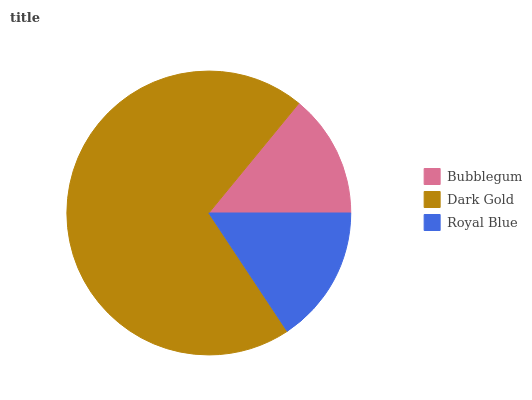Is Bubblegum the minimum?
Answer yes or no. Yes. Is Dark Gold the maximum?
Answer yes or no. Yes. Is Royal Blue the minimum?
Answer yes or no. No. Is Royal Blue the maximum?
Answer yes or no. No. Is Dark Gold greater than Royal Blue?
Answer yes or no. Yes. Is Royal Blue less than Dark Gold?
Answer yes or no. Yes. Is Royal Blue greater than Dark Gold?
Answer yes or no. No. Is Dark Gold less than Royal Blue?
Answer yes or no. No. Is Royal Blue the high median?
Answer yes or no. Yes. Is Royal Blue the low median?
Answer yes or no. Yes. Is Dark Gold the high median?
Answer yes or no. No. Is Dark Gold the low median?
Answer yes or no. No. 